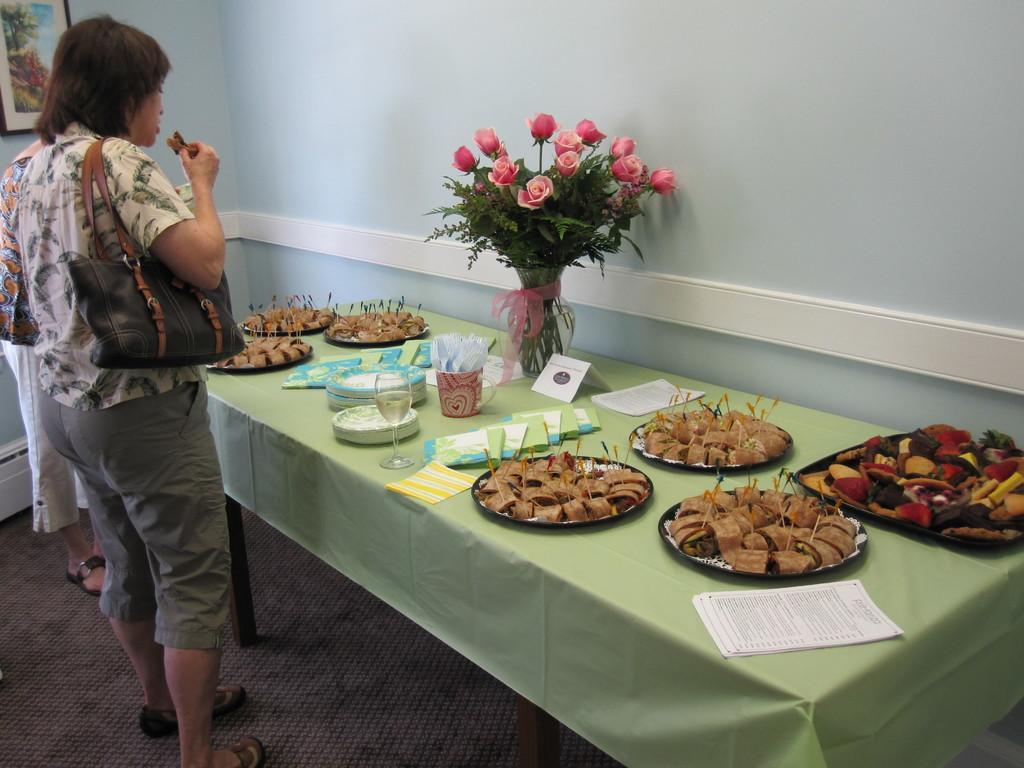Please provide a concise description of this image. In this image I can see a woman standing with a handbag. On table there is a plate,food,glass and a bouquet. 